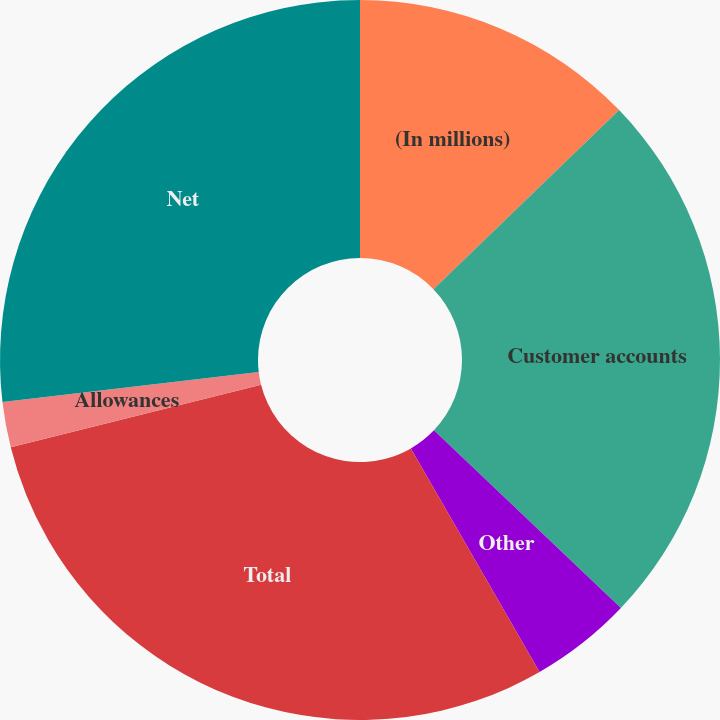Convert chart. <chart><loc_0><loc_0><loc_500><loc_500><pie_chart><fcel>(In millions)<fcel>Customer accounts<fcel>Other<fcel>Total<fcel>Allowances<fcel>Net<nl><fcel>12.79%<fcel>24.31%<fcel>4.59%<fcel>29.41%<fcel>2.04%<fcel>26.86%<nl></chart> 